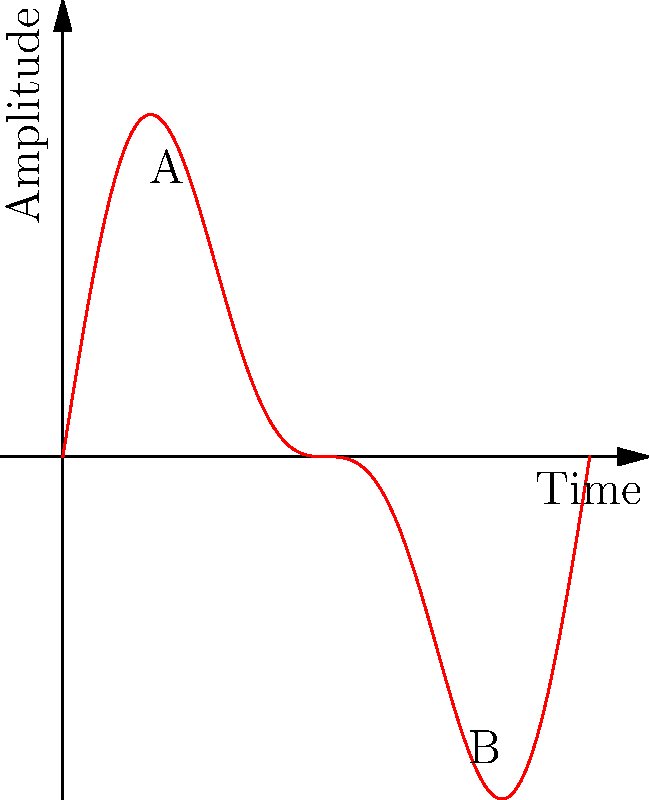In the context of fractal patterns in musical compositions and their potential connections to political structures, consider the waveform shown above. If this waveform represents a musical phrase, and we apply a transformation that reflects the phrase across the vertical axis at x = 0.5 and then scales it horizontally by a factor of 0.5, what would be the coordinates of point B after the transformation? To solve this problem, we need to follow these steps:

1. Identify the original coordinates of point B:
   The original point B is at (0.75, f(0.75)).

2. Apply the reflection across the vertical axis at x = 0.5:
   - The distance of B from the axis of reflection is 0.75 - 0.5 = 0.25
   - After reflection, the x-coordinate becomes 0.5 - 0.25 = 0.25
   - The y-coordinate remains unchanged

3. Apply the horizontal scaling by a factor of 0.5:
   - The distance of the reflected point from x = 0.5 is 0.5 - 0.25 = 0.25
   - This distance is scaled by 0.5, becoming 0.25 * 0.5 = 0.125
   - The new x-coordinate is 0.5 - 0.125 = 0.375

4. The final coordinates of B after transformation are (0.375, f(0.75)).

This transformation can be seen as a metaphor for how political structures might influence musical compositions, compressing and reflecting certain elements while preserving others.
Answer: (0.375, f(0.75)) 